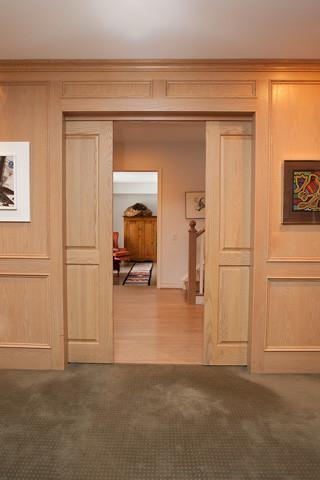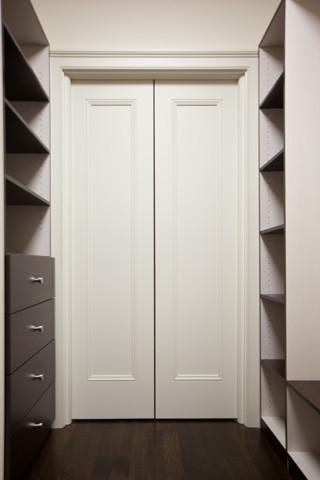The first image is the image on the left, the second image is the image on the right. Examine the images to the left and right. Is the description "One sliding door is partially open and showing a bathroom behind it." accurate? Answer yes or no. No. The first image is the image on the left, the second image is the image on the right. Assess this claim about the two images: "One image shows a doorway with a single white door in a head-on view, and the door is half-closed with the left half open.". Correct or not? Answer yes or no. No. 